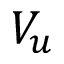Convert formula to latex. <formula><loc_0><loc_0><loc_500><loc_500>V _ { u }</formula> 